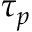<formula> <loc_0><loc_0><loc_500><loc_500>\tau _ { p }</formula> 